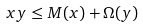<formula> <loc_0><loc_0><loc_500><loc_500>x y \leq M ( x ) + \Omega ( y )</formula> 